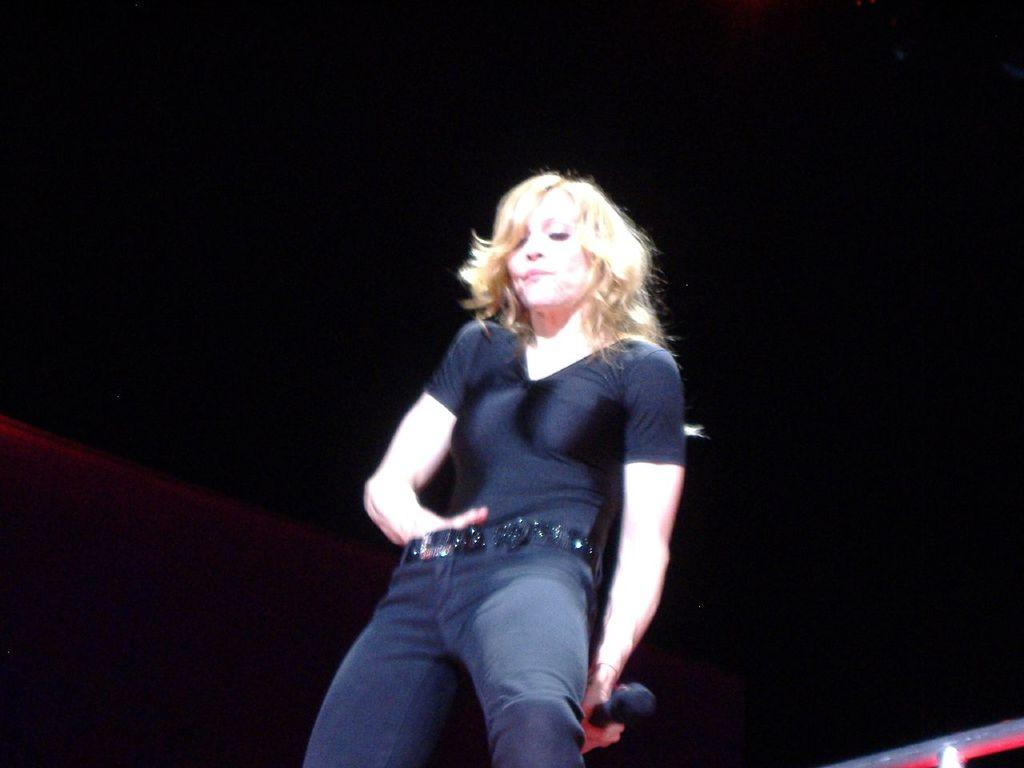Who is the main subject in the image? There is a woman in the image. What is the woman wearing? The woman is wearing a black dress. What is the woman holding in her hand? The woman is holding a mic in her hand. What can be observed about the background of the image? The background of the image is dark. What type of flowers can be seen in the woman's hair in the image? There are no flowers present in the image, nor are there any on the woman's hair. 